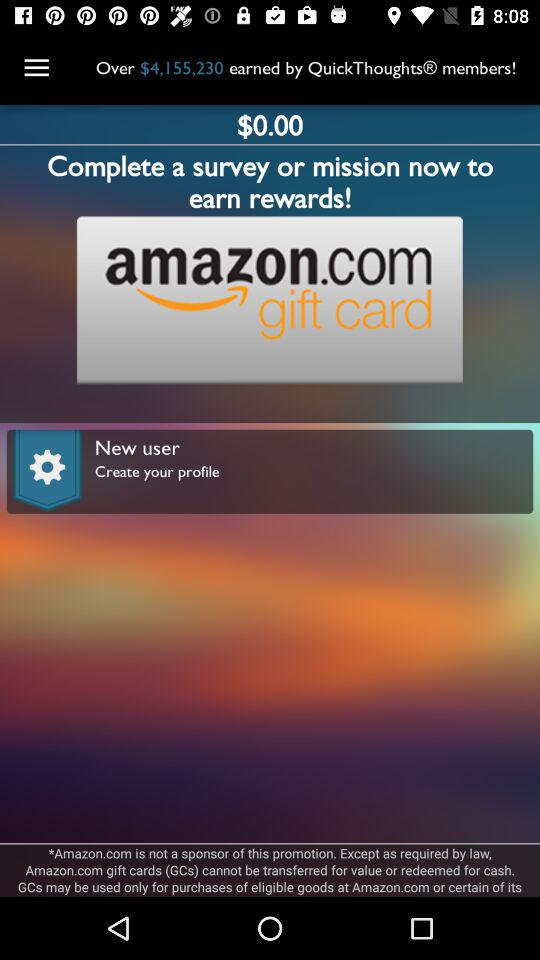What is the profile name?
When the provided information is insufficient, respond with <no answer>. <no answer> 